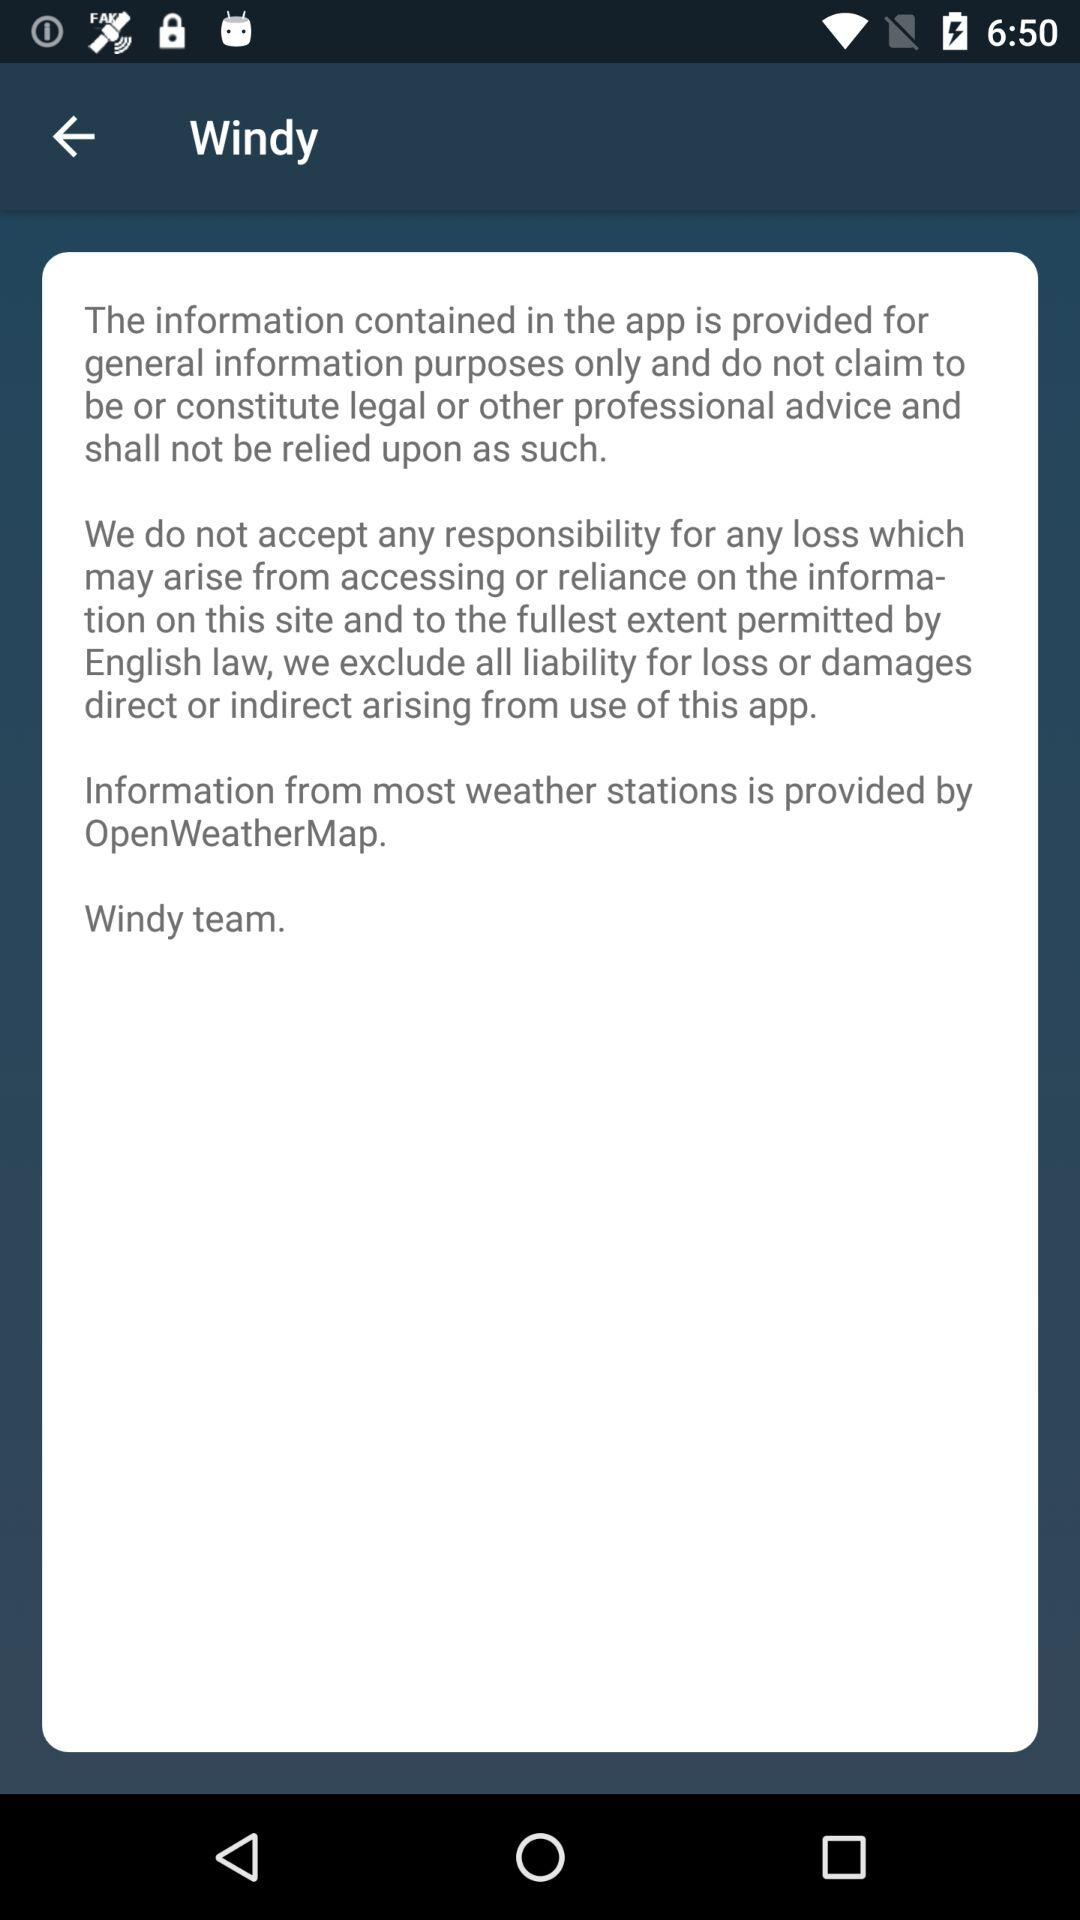What is the application name? The application name is "Windy". 